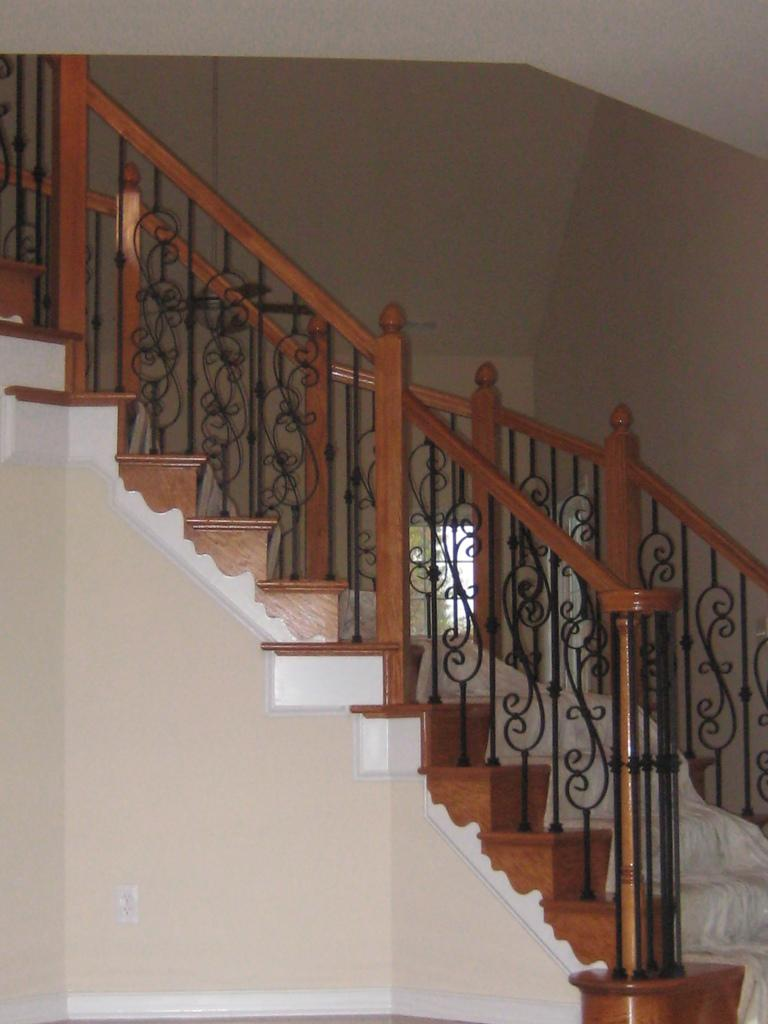What is the main feature in the center of the image? There is a staircase in the center of the image. What is placed on the staircase? There is a cloth on the staircase. What is used for support on the staircase? There is a railing on the staircase. What can be seen in the background of the image? There is a wall and a window in the background of the image. How many centimeters of hair are being cut in the image? There is no haircut or measurement of hair in the image; it features a staircase with a cloth and railing, along with a wall and window in the background. 